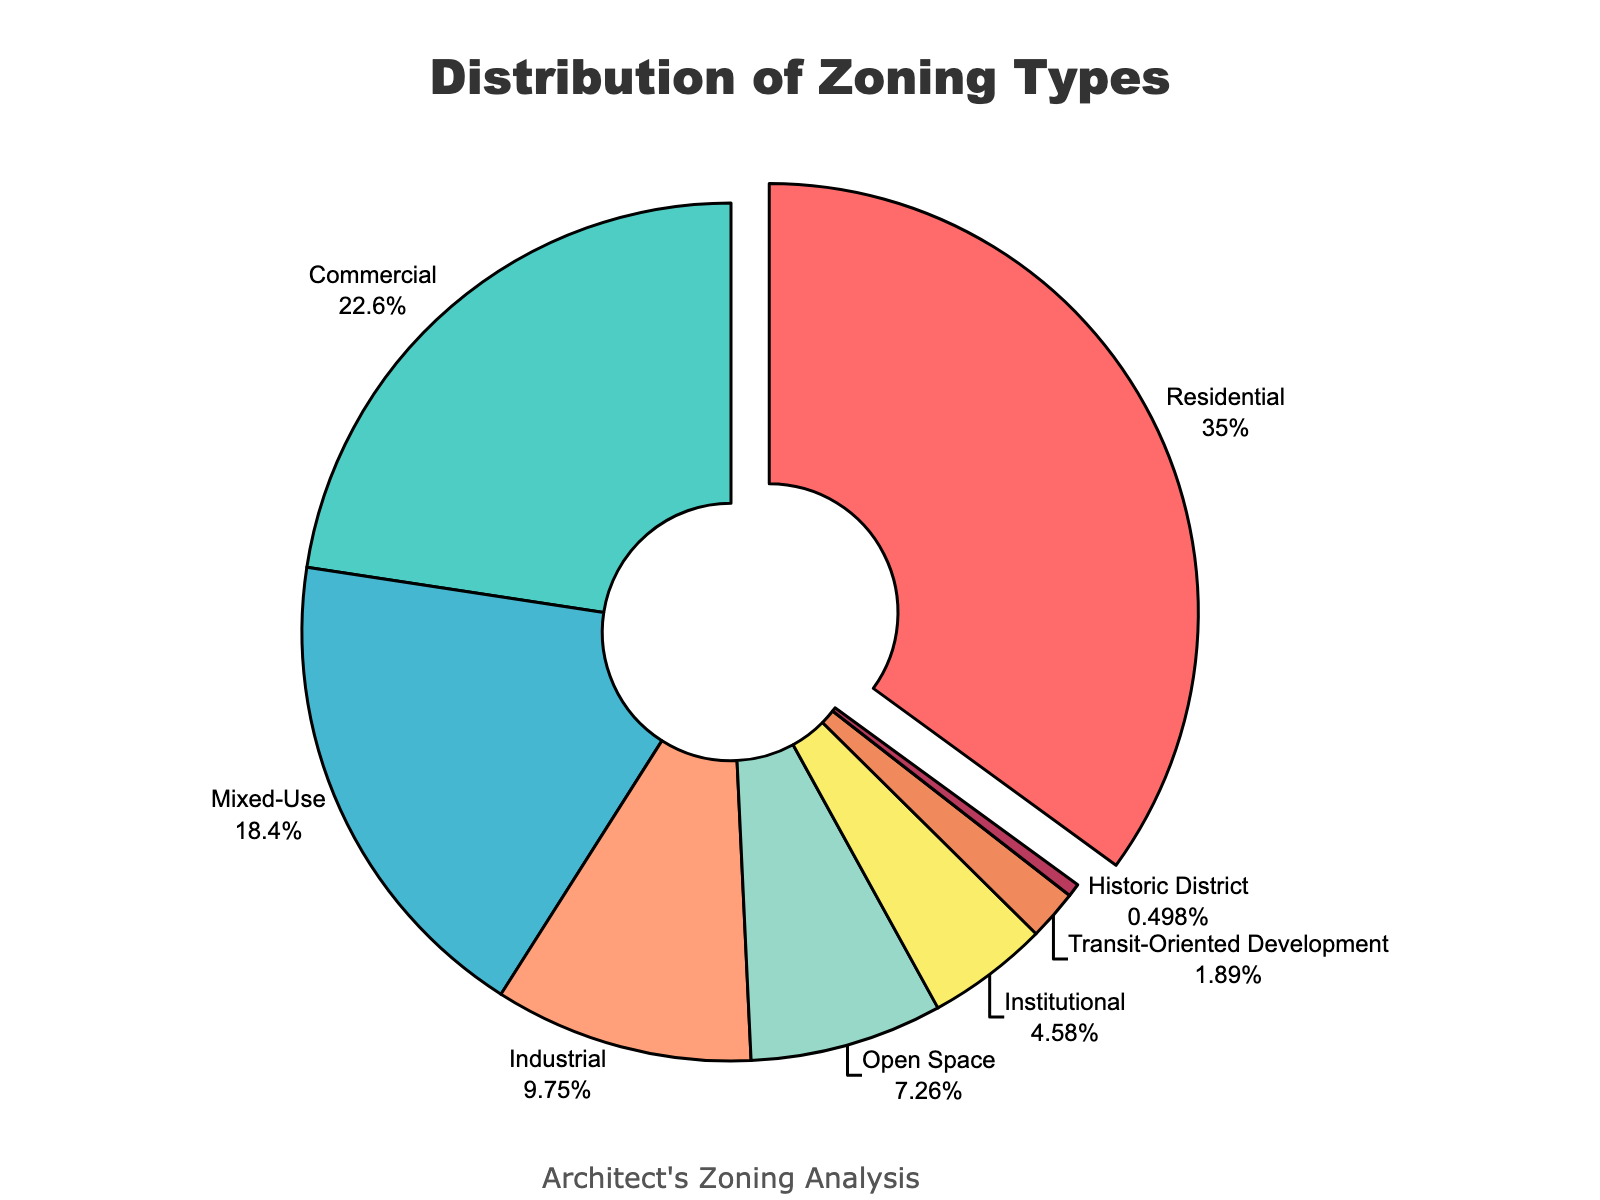Which zoning type has the highest percentage? Identify the slice that is pulled out from the pie chart, which represents the largest percentage. The label shows Residential as 35.2%.
Answer: Residential Which zoning type has the smallest percentage? Look for the smallest slice in the pie chart. The label on that slice indicates Historic District at 0.5%.
Answer: Historic District What is the combined percentage of Residential and Commercial zones? Add the percentages for Residential (35.2%) and Commercial (22.7%). 35.2 + 22.7 = 57.9%.
Answer: 57.9% How much greater is the percentage of Residential zoning compared to Industrial zoning? Subtract the Industrial percentage (9.8%) from the Residential percentage (35.2%). 35.2 - 9.8 = 25.4%.
Answer: 25.4% Which two zoning types have the closest percentages? Compare the percentages given; Mixed-Use at 18.5% and Industrial at 9.8% are not close. Continue comparing and find that Open Space (7.3%) and Institutional (4.6%) are closer.
Answer: Open Space and Institutional What is the total percentage of Mixed-Use, Industrial, and Open Space zoning types? Sum their percentages: Mixed-Use (18.5%) + Industrial (9.8%) + Open Space (7.3%). 18.5 + 9.8 + 7.3 = 35.6%.
Answer: 35.6% How much less is the percentage of Transit-Oriented Development compared to Commercial zoning? Subtract the percentage of Transit-Oriented Development (1.9%) from Commercial (22.7%). 22.7 - 1.9 = 20.8%.
Answer: 20.8% Which color represents Mixed-Use zones in the chart? Identify the color used for the Mixed-Use slice from the legend or the pie chart itself. The Mixed-Use slice is likely cyan.
Answer: Cyan What is the difference in percentage between the highest and lowest zoning types? Subtract the lowest percentage (Historic District, 0.5%) from the highest percentage (Residential, 35.2%). 35.2 - 0.5 = 34.7%.
Answer: 34.7% What is the combined percentage of all zoning types except Residential? Subtract the percentage of Residential (35.2%) from 100%. 100 - 35.2 = 64.8%.
Answer: 64.8% 